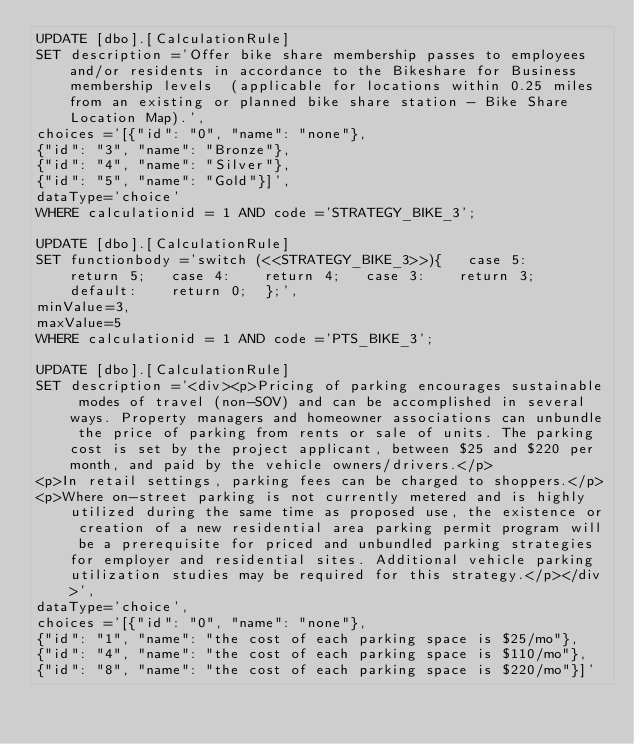Convert code to text. <code><loc_0><loc_0><loc_500><loc_500><_SQL_>UPDATE [dbo].[CalculationRule]
SET description ='Offer bike share membership passes to employees and/or residents in accordance to the Bikeshare for Business  membership levels  (applicable for locations within 0.25 miles from an existing or planned bike share station - Bike Share Location Map).',
choices ='[{"id": "0", "name": "none"},
{"id": "3", "name": "Bronze"},
{"id": "4", "name": "Silver"},
{"id": "5", "name": "Gold"}]',
dataType='choice'
WHERE calculationid = 1 AND code ='STRATEGY_BIKE_3';

UPDATE [dbo].[CalculationRule]
SET functionbody ='switch (<<STRATEGY_BIKE_3>>){   case 5:    return 5;   case 4:    return 4;   case 3:    return 3;  default:    return 0;  };',
minValue=3,
maxValue=5
WHERE calculationid = 1 AND code ='PTS_BIKE_3';

UPDATE [dbo].[CalculationRule]
SET description ='<div><p>Pricing of parking encourages sustainable modes of travel (non-SOV) and can be accomplished in several ways. Property managers and homeowner associations can unbundle the price of parking from rents or sale of units. The parking cost is set by the project applicant, between $25 and $220 per month, and paid by the vehicle owners/drivers.</p>
<p>In retail settings, parking fees can be charged to shoppers.</p>
<p>Where on-street parking is not currently metered and is highly utilized during the same time as proposed use, the existence or creation of a new residential area parking permit program will be a prerequisite for priced and unbundled parking strategies for employer and residential sites. Additional vehicle parking utilization studies may be required for this strategy.</p></div>',
dataType='choice',
choices ='[{"id": "0", "name": "none"},
{"id": "1", "name": "the cost of each parking space is $25/mo"},
{"id": "4", "name": "the cost of each parking space is $110/mo"},
{"id": "8", "name": "the cost of each parking space is $220/mo"}]'</code> 